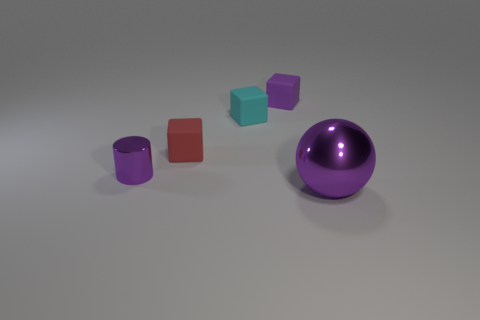How many objects are either objects that are left of the large purple object or small objects that are behind the tiny cylinder?
Your response must be concise. 4. Are there an equal number of purple metallic balls that are in front of the purple sphere and gray matte blocks?
Give a very brief answer. Yes. There is a thing in front of the metal cylinder; is its size the same as the purple object that is behind the small purple metallic thing?
Make the answer very short. No. What number of other objects are the same size as the cyan matte cube?
Keep it short and to the point. 3. There is a metal thing that is in front of the purple metallic thing that is to the left of the red rubber cube; is there a big thing to the right of it?
Keep it short and to the point. No. Is there anything else that has the same color as the large metallic ball?
Your answer should be compact. Yes. What is the size of the matte thing that is in front of the cyan rubber object?
Offer a terse response. Small. There is a purple shiny thing that is on the right side of the tiny purple object that is in front of the tiny thing that is right of the small cyan matte object; what size is it?
Provide a succinct answer. Large. There is a thing in front of the tiny purple object in front of the cyan block; what color is it?
Your answer should be very brief. Purple. There is a purple object that is the same shape as the tiny red object; what is its material?
Provide a succinct answer. Rubber. 